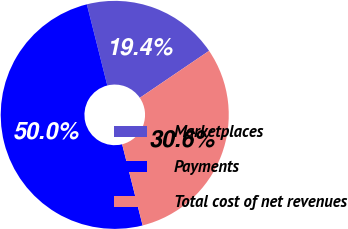Convert chart. <chart><loc_0><loc_0><loc_500><loc_500><pie_chart><fcel>Marketplaces<fcel>Payments<fcel>Total cost of net revenues<nl><fcel>19.44%<fcel>50.0%<fcel>30.56%<nl></chart> 